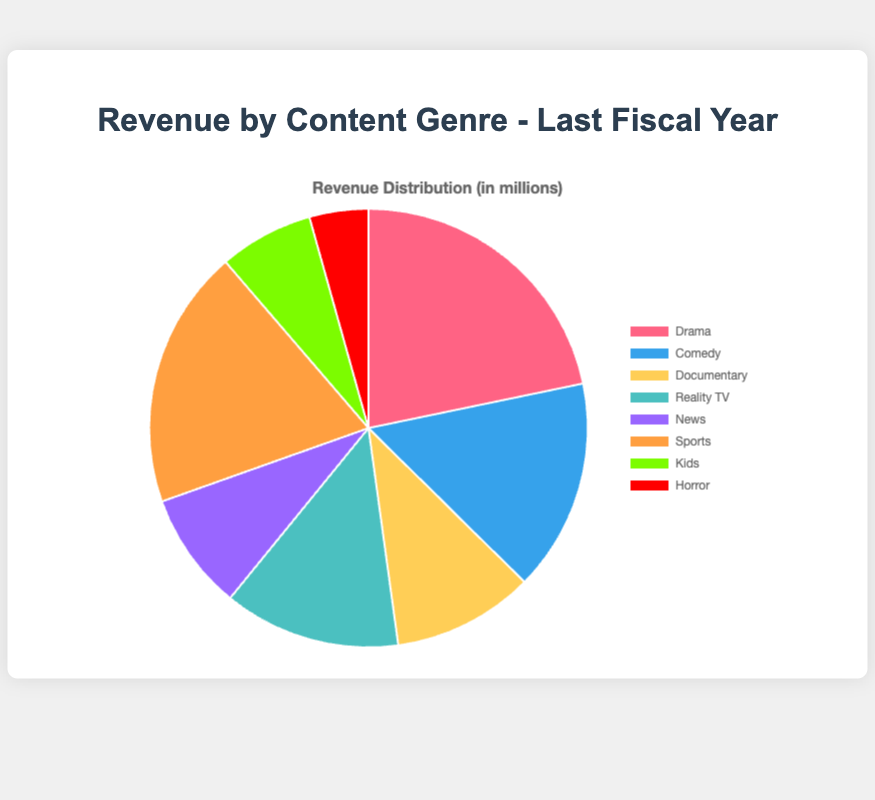What genre generated the most revenue? The genre with the largest section of the pie chart represents the highest revenue. This section is labeled "Drama."
Answer: Drama Which genre generated the least revenue? The genre with the smallest section of the pie chart represents the least revenue. This section is labeled "Horror."
Answer: Horror What is the total revenue generated by Sports and News genres combined? Adding the revenues from Sports ($22,000,000) and News ($10,000,000) gives a total: $22,000,000 + $10,000,000 = $32,000,000.
Answer: $32,000,000 Did Comedy or Reality TV generate more revenue, and by how much? Comparing the revenues, Comedy generated $18,000,000 while Reality TV generated $15,000,000. The difference is $18,000,000 - $15,000,000 = $3,000,000.
Answer: Comedy generated $3,000,000 more revenue How much more revenue did Drama generate compared to Kids? Drama generated $25,000,000 while Kids generated $8,000,000. The difference is $25,000,000 - $8,000,000 = $17,000,000.
Answer: $17,000,000 more What proportion of the total revenue did the Horror genre account for? The total revenue is the sum of all genre revenues, $25,000,000 (Drama) + $18,000,000 (Comedy) + $12,000,000 (Documentary) + $15,000,000 (Reality TV) + $10,000,000 (News) + $22,000,000 (Sports) + $8,000,000 (Kids) + $5,000,000 (Horror) = $115,000,000. The proportion for Horror is ($5,000,000 / $115,000,000) * 100% ≈ 4.35%.
Answer: 4.35% Which genre's revenue is closest to the average revenue per genre? The average revenue per genre is the total revenue divided by the number of genres: $115,000,000 / 8 = $14,375,000. Reality TV's revenue of $15,000,000 is closest to this average.
Answer: Reality TV List the genres with revenue higher than News but lower than Comedy. News generated $10,000,000, and Comedy generated $18,000,000. The genres with revenue in this range are Documentary ($12,000,000) and Reality TV ($15,000,000).
Answer: Documentary and Reality TV Which two genres together generate more revenue than Drama alone? Drama generated $25,000,000. Adding the revenues for various pairs of genres: 
Sports + Comedy = $22,000,000 + $18,000,000 = $40,000,000
Sports + Documentary = $22,000,000 + $12,000,000 = $34,000,000
Comedy + Documentary = $18,000,000 + $12,000,000 = $30,000,000
Any of these pairs (Sports + Comedy, Sports + Documentary, and Comedy + Documentary) generate more than Drama alone.
Answer: Sports + Comedy, Sports + Documentary, and Comedy + Documentary 